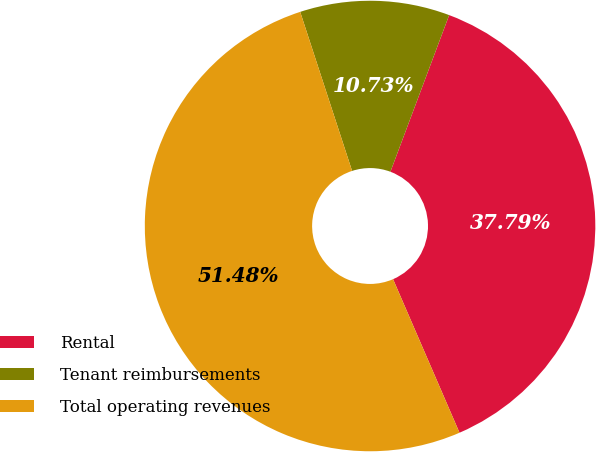Convert chart to OTSL. <chart><loc_0><loc_0><loc_500><loc_500><pie_chart><fcel>Rental<fcel>Tenant reimbursements<fcel>Total operating revenues<nl><fcel>37.79%<fcel>10.73%<fcel>51.48%<nl></chart> 